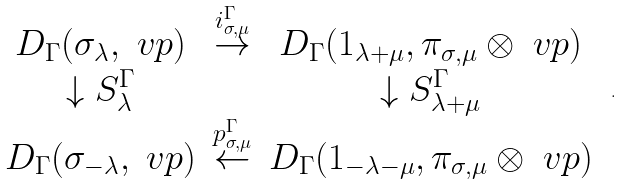Convert formula to latex. <formula><loc_0><loc_0><loc_500><loc_500>\begin{array} { c c c } D _ { \Gamma } ( \sigma _ { \lambda } , \ v p ) & \stackrel { i ^ { \Gamma } _ { \sigma , \mu } } { \rightarrow } & D _ { \Gamma } ( 1 _ { \lambda + \mu } , \pi _ { \sigma , \mu } \otimes \ v p ) \\ \downarrow S ^ { \Gamma } _ { \lambda } & & \downarrow S ^ { \Gamma } _ { \lambda + \mu } \\ D _ { \Gamma } ( \sigma _ { - \lambda } , \ v p ) & \stackrel { p ^ { \Gamma } _ { \sigma , \mu } } { \leftarrow } & D _ { \Gamma } ( 1 _ { - \lambda - \mu } , \pi _ { \sigma , \mu } \otimes \ v p ) \end{array} \ .</formula> 